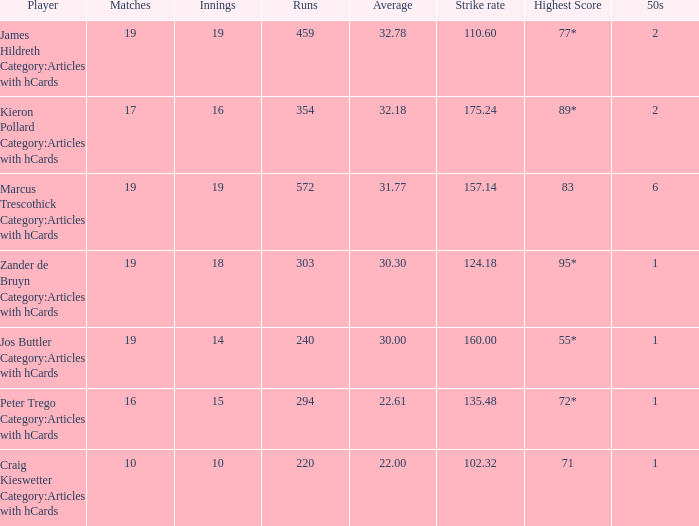What is the top score for the player with a mean of 3 55*. 